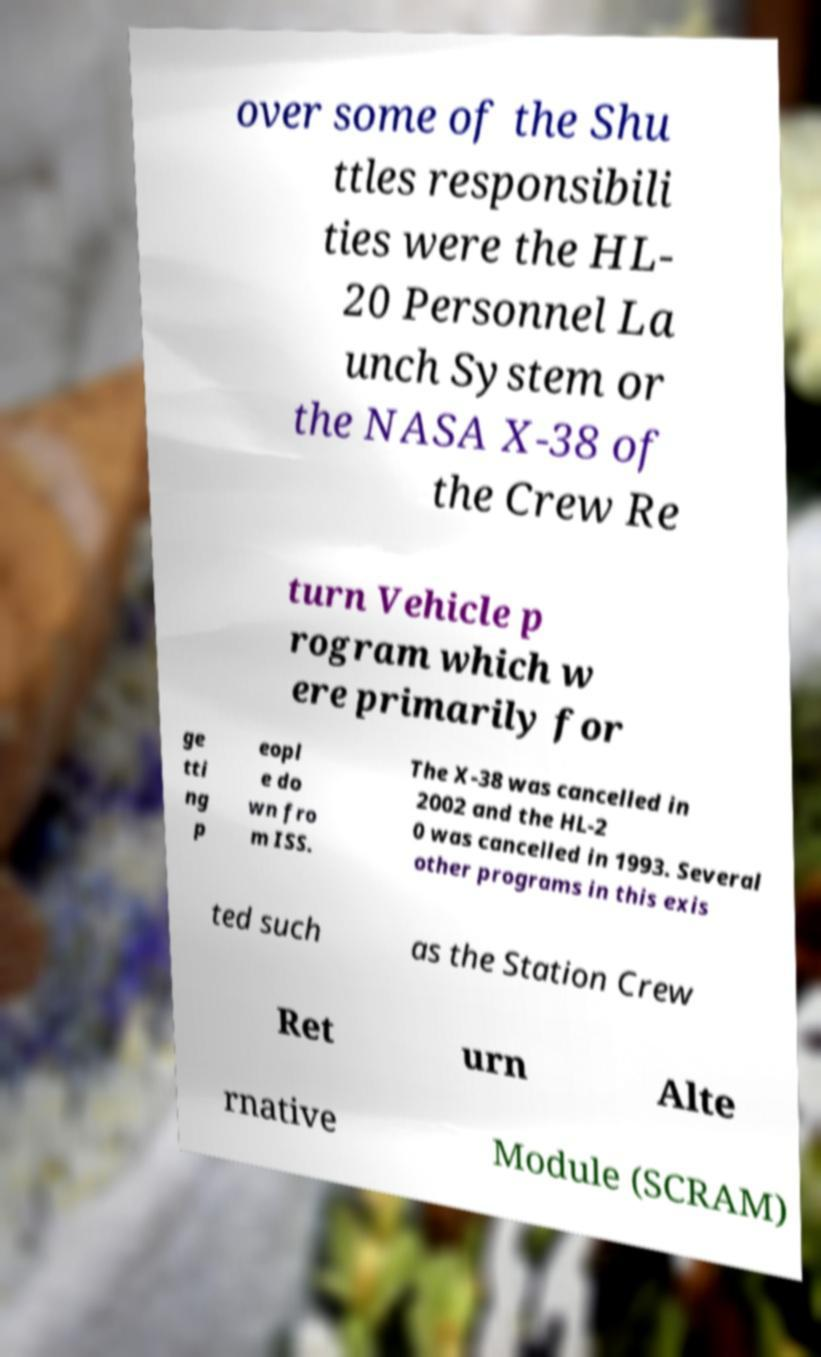Can you read and provide the text displayed in the image?This photo seems to have some interesting text. Can you extract and type it out for me? over some of the Shu ttles responsibili ties were the HL- 20 Personnel La unch System or the NASA X-38 of the Crew Re turn Vehicle p rogram which w ere primarily for ge tti ng p eopl e do wn fro m ISS. The X-38 was cancelled in 2002 and the HL-2 0 was cancelled in 1993. Several other programs in this exis ted such as the Station Crew Ret urn Alte rnative Module (SCRAM) 